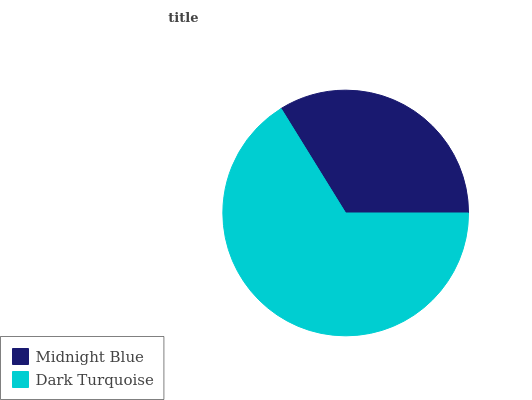Is Midnight Blue the minimum?
Answer yes or no. Yes. Is Dark Turquoise the maximum?
Answer yes or no. Yes. Is Dark Turquoise the minimum?
Answer yes or no. No. Is Dark Turquoise greater than Midnight Blue?
Answer yes or no. Yes. Is Midnight Blue less than Dark Turquoise?
Answer yes or no. Yes. Is Midnight Blue greater than Dark Turquoise?
Answer yes or no. No. Is Dark Turquoise less than Midnight Blue?
Answer yes or no. No. Is Dark Turquoise the high median?
Answer yes or no. Yes. Is Midnight Blue the low median?
Answer yes or no. Yes. Is Midnight Blue the high median?
Answer yes or no. No. Is Dark Turquoise the low median?
Answer yes or no. No. 